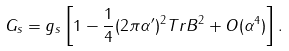<formula> <loc_0><loc_0><loc_500><loc_500>G _ { s } = g _ { s } \left [ 1 - \frac { 1 } { 4 } ( 2 \pi \alpha ^ { \prime } ) ^ { 2 } T r B ^ { 2 } + O ( \alpha ^ { 4 } ) \right ] .</formula> 